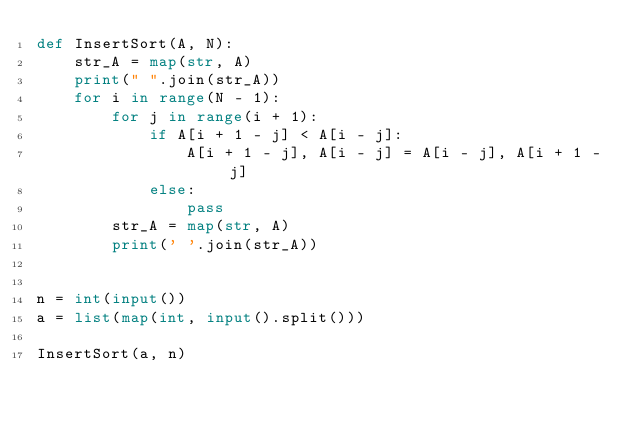Convert code to text. <code><loc_0><loc_0><loc_500><loc_500><_Python_>def InsertSort(A, N): 
    str_A = map(str, A)
    print(" ".join(str_A))
    for i in range(N - 1):
        for j in range(i + 1):
            if A[i + 1 - j] < A[i - j]:
                A[i + 1 - j], A[i - j] = A[i - j], A[i + 1 - j]
            else:
                pass
        str_A = map(str, A)
        print(' '.join(str_A))


n = int(input())
a = list(map(int, input().split()))

InsertSort(a, n)
</code> 